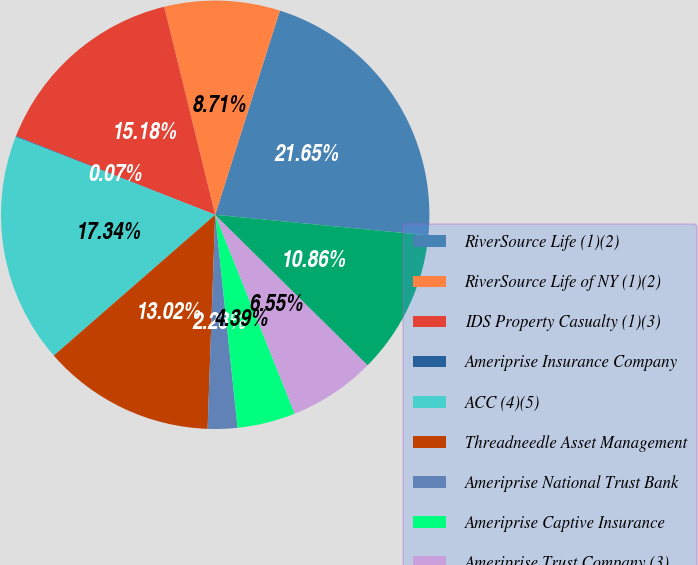Convert chart. <chart><loc_0><loc_0><loc_500><loc_500><pie_chart><fcel>RiverSource Life (1)(2)<fcel>RiverSource Life of NY (1)(2)<fcel>IDS Property Casualty (1)(3)<fcel>Ameriprise Insurance Company<fcel>ACC (4)(5)<fcel>Threadneedle Asset Management<fcel>Ameriprise National Trust Bank<fcel>Ameriprise Captive Insurance<fcel>Ameriprise Trust Company (3)<fcel>AEIS (3)(4)<nl><fcel>21.65%<fcel>8.71%<fcel>15.18%<fcel>0.07%<fcel>17.34%<fcel>13.02%<fcel>2.23%<fcel>4.39%<fcel>6.55%<fcel>10.86%<nl></chart> 